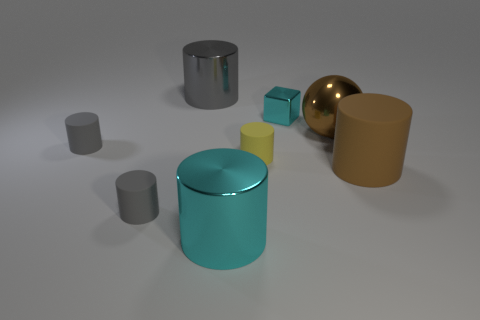Add 2 small rubber cylinders. How many objects exist? 10 Subtract all gray metal cylinders. How many cylinders are left? 5 Subtract all yellow blocks. How many gray cylinders are left? 3 Subtract all gray cylinders. How many cylinders are left? 3 Subtract all cylinders. How many objects are left? 2 Subtract 0 gray balls. How many objects are left? 8 Subtract all red cylinders. Subtract all green balls. How many cylinders are left? 6 Subtract all large gray metallic objects. Subtract all large brown balls. How many objects are left? 6 Add 7 gray metallic cylinders. How many gray metallic cylinders are left? 8 Add 5 tiny yellow cylinders. How many tiny yellow cylinders exist? 6 